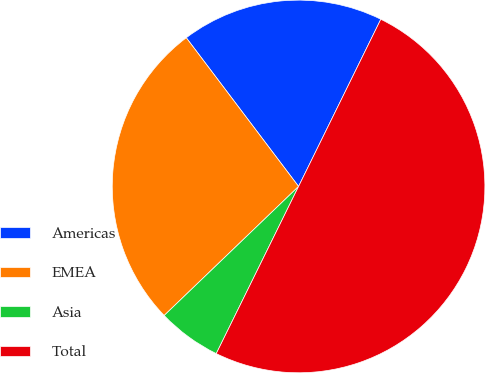Convert chart to OTSL. <chart><loc_0><loc_0><loc_500><loc_500><pie_chart><fcel>Americas<fcel>EMEA<fcel>Asia<fcel>Total<nl><fcel>17.57%<fcel>26.88%<fcel>5.54%<fcel>50.0%<nl></chart> 